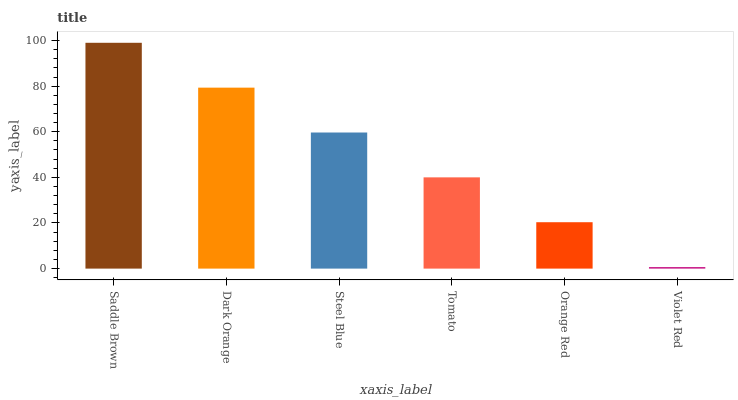Is Dark Orange the minimum?
Answer yes or no. No. Is Dark Orange the maximum?
Answer yes or no. No. Is Saddle Brown greater than Dark Orange?
Answer yes or no. Yes. Is Dark Orange less than Saddle Brown?
Answer yes or no. Yes. Is Dark Orange greater than Saddle Brown?
Answer yes or no. No. Is Saddle Brown less than Dark Orange?
Answer yes or no. No. Is Steel Blue the high median?
Answer yes or no. Yes. Is Tomato the low median?
Answer yes or no. Yes. Is Dark Orange the high median?
Answer yes or no. No. Is Violet Red the low median?
Answer yes or no. No. 